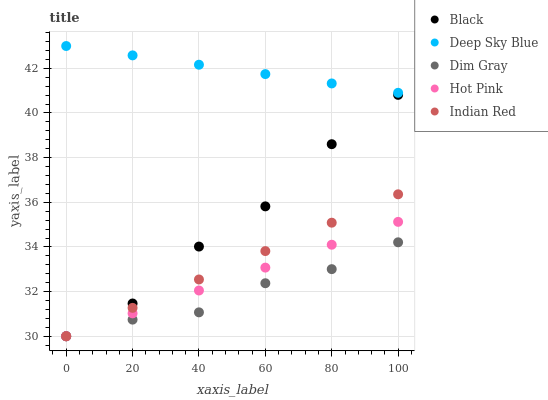Does Dim Gray have the minimum area under the curve?
Answer yes or no. Yes. Does Deep Sky Blue have the maximum area under the curve?
Answer yes or no. Yes. Does Black have the minimum area under the curve?
Answer yes or no. No. Does Black have the maximum area under the curve?
Answer yes or no. No. Is Indian Red the smoothest?
Answer yes or no. Yes. Is Black the roughest?
Answer yes or no. Yes. Is Black the smoothest?
Answer yes or no. No. Is Indian Red the roughest?
Answer yes or no. No. Does Dim Gray have the lowest value?
Answer yes or no. Yes. Does Deep Sky Blue have the lowest value?
Answer yes or no. No. Does Deep Sky Blue have the highest value?
Answer yes or no. Yes. Does Black have the highest value?
Answer yes or no. No. Is Indian Red less than Deep Sky Blue?
Answer yes or no. Yes. Is Deep Sky Blue greater than Black?
Answer yes or no. Yes. Does Indian Red intersect Hot Pink?
Answer yes or no. Yes. Is Indian Red less than Hot Pink?
Answer yes or no. No. Is Indian Red greater than Hot Pink?
Answer yes or no. No. Does Indian Red intersect Deep Sky Blue?
Answer yes or no. No. 